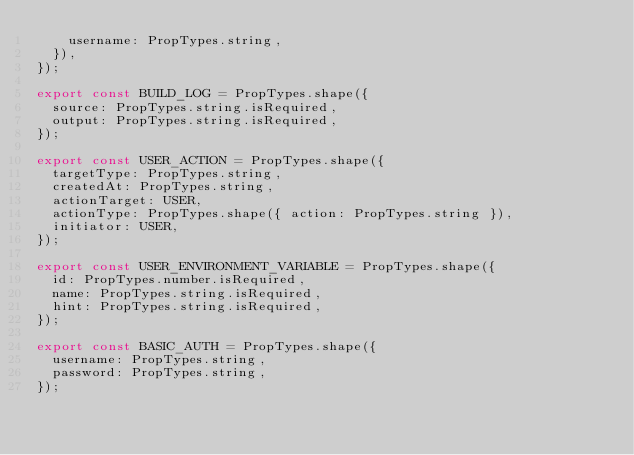Convert code to text. <code><loc_0><loc_0><loc_500><loc_500><_JavaScript_>    username: PropTypes.string,
  }),
});

export const BUILD_LOG = PropTypes.shape({
  source: PropTypes.string.isRequired,
  output: PropTypes.string.isRequired,
});

export const USER_ACTION = PropTypes.shape({
  targetType: PropTypes.string,
  createdAt: PropTypes.string,
  actionTarget: USER,
  actionType: PropTypes.shape({ action: PropTypes.string }),
  initiator: USER,
});

export const USER_ENVIRONMENT_VARIABLE = PropTypes.shape({
  id: PropTypes.number.isRequired,
  name: PropTypes.string.isRequired,
  hint: PropTypes.string.isRequired,
});

export const BASIC_AUTH = PropTypes.shape({
  username: PropTypes.string,
  password: PropTypes.string,
});
</code> 